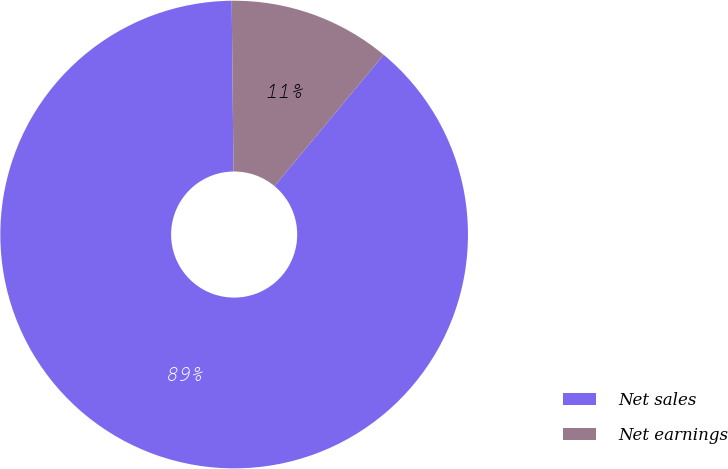Convert chart to OTSL. <chart><loc_0><loc_0><loc_500><loc_500><pie_chart><fcel>Net sales<fcel>Net earnings<nl><fcel>88.79%<fcel>11.21%<nl></chart> 